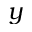Convert formula to latex. <formula><loc_0><loc_0><loc_500><loc_500>y</formula> 